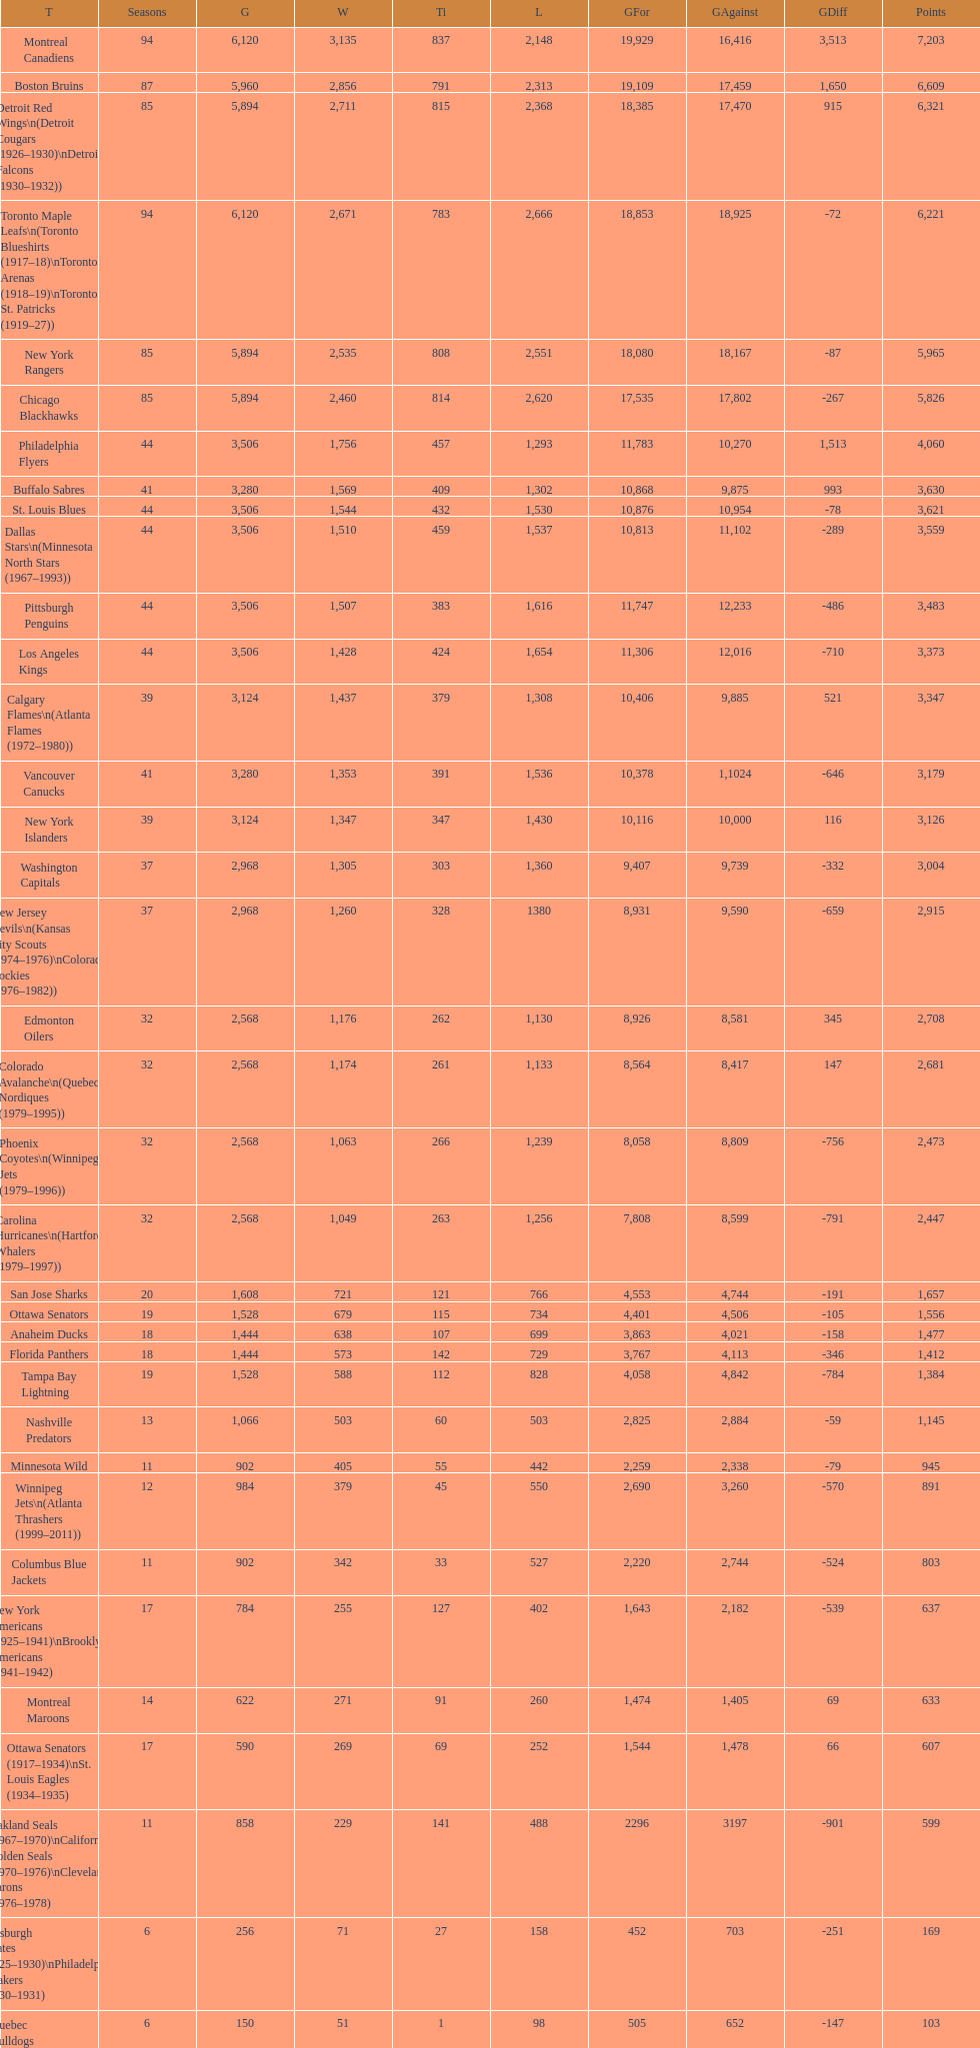Which team was last in terms of points up until this point? Montreal Wanderers. 